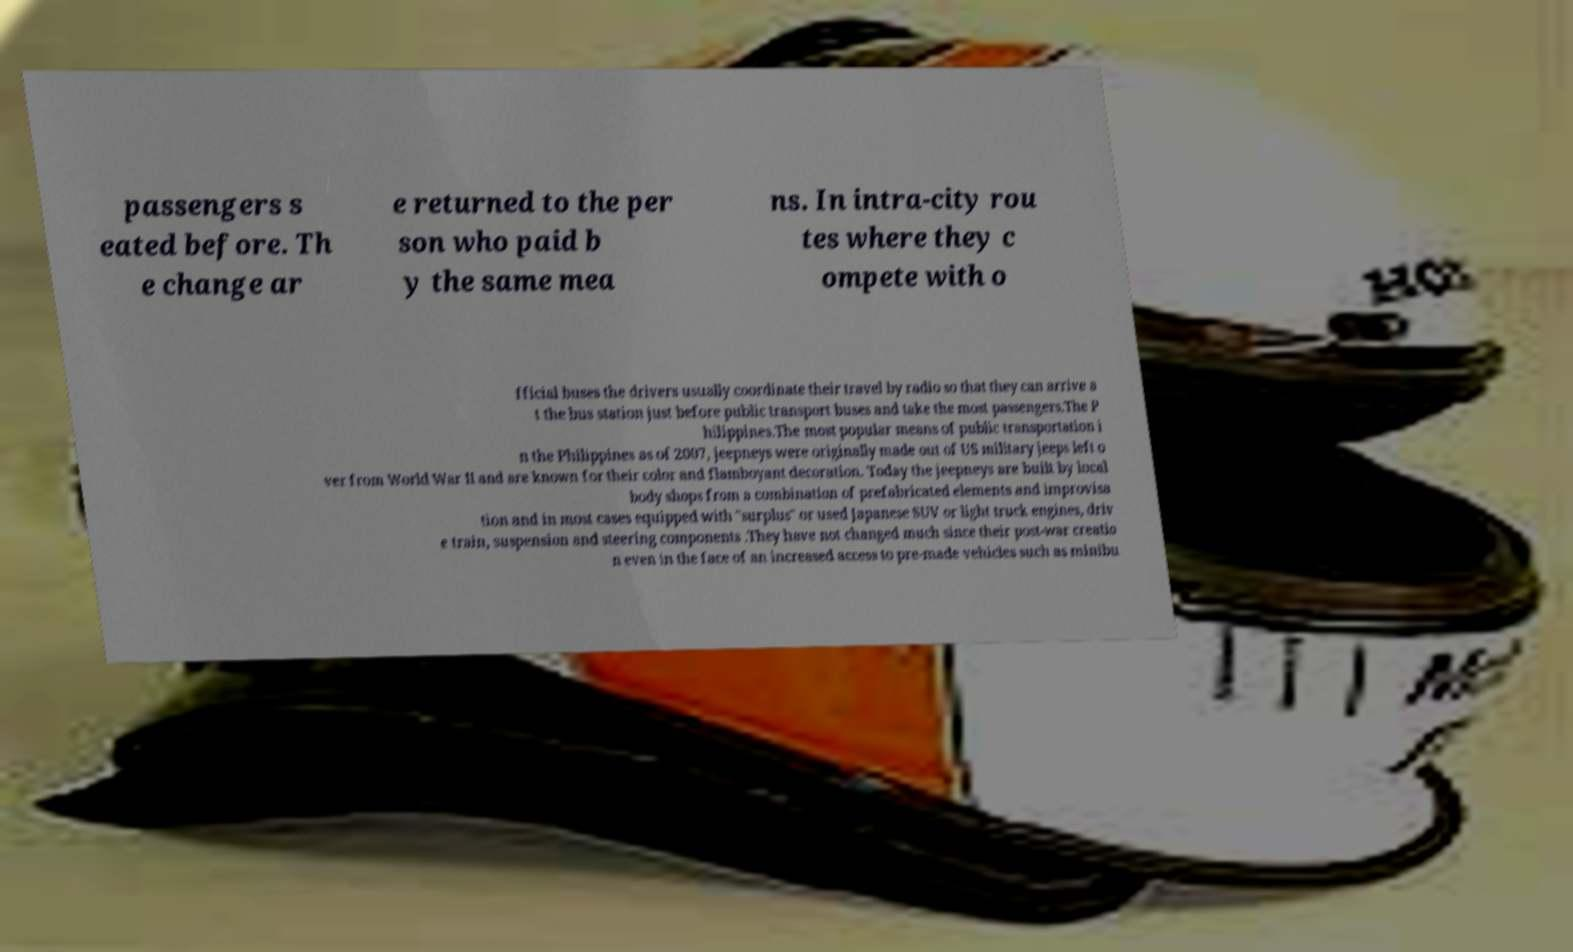Could you assist in decoding the text presented in this image and type it out clearly? passengers s eated before. Th e change ar e returned to the per son who paid b y the same mea ns. In intra-city rou tes where they c ompete with o fficial buses the drivers usually coordinate their travel by radio so that they can arrive a t the bus station just before public transport buses and take the most passengers.The P hilippines.The most popular means of public transportation i n the Philippines as of 2007, jeepneys were originally made out of US military jeeps left o ver from World War II and are known for their color and flamboyant decoration. Today the jeepneys are built by local body shops from a combination of prefabricated elements and improvisa tion and in most cases equipped with "surplus" or used Japanese SUV or light truck engines, driv e train, suspension and steering components .They have not changed much since their post-war creatio n even in the face of an increased access to pre-made vehicles such as minibu 